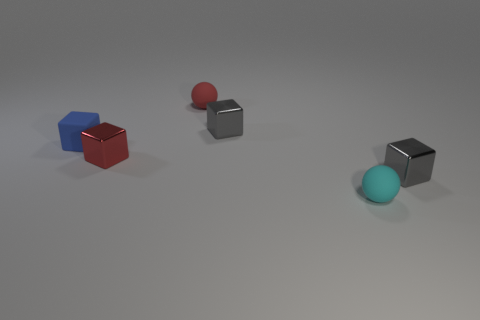Subtract all green balls. How many gray blocks are left? 2 Subtract all blue blocks. How many blocks are left? 3 Subtract 2 cubes. How many cubes are left? 2 Subtract all red blocks. How many blocks are left? 3 Subtract all balls. How many objects are left? 4 Add 1 gray metallic blocks. How many objects exist? 7 Subtract 0 cyan cylinders. How many objects are left? 6 Subtract all brown blocks. Subtract all gray cylinders. How many blocks are left? 4 Subtract all red metallic blocks. Subtract all small spheres. How many objects are left? 3 Add 5 tiny blue rubber things. How many tiny blue rubber things are left? 6 